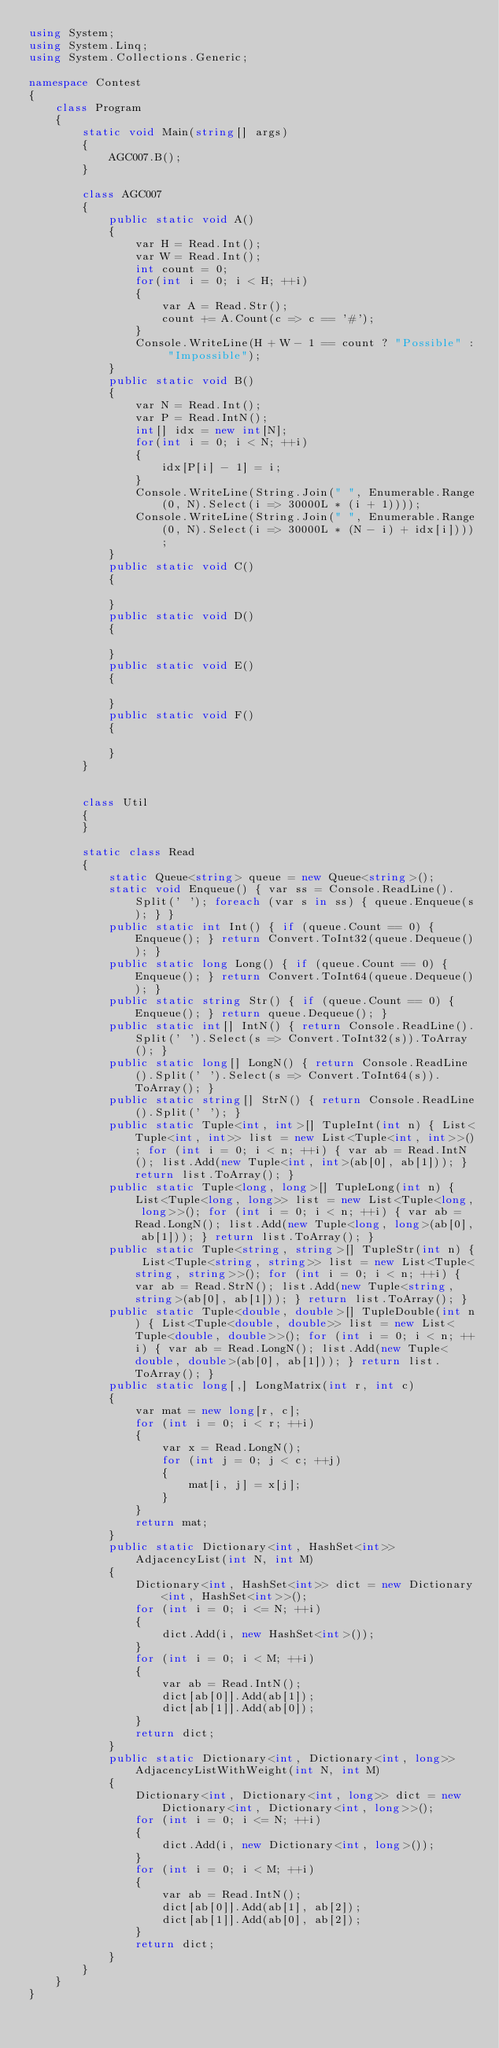Convert code to text. <code><loc_0><loc_0><loc_500><loc_500><_C#_>using System;
using System.Linq;
using System.Collections.Generic;

namespace Contest
{
    class Program
    {
        static void Main(string[] args)
        {
            AGC007.B();
        }

        class AGC007
        {
            public static void A()
            {
                var H = Read.Int();
                var W = Read.Int();
                int count = 0;
                for(int i = 0; i < H; ++i)
                {
                    var A = Read.Str();
                    count += A.Count(c => c == '#');
                }
                Console.WriteLine(H + W - 1 == count ? "Possible" : "Impossible");
            }
            public static void B()
            {
                var N = Read.Int();
                var P = Read.IntN();
                int[] idx = new int[N];
                for(int i = 0; i < N; ++i)
                {
                    idx[P[i] - 1] = i;
                }
                Console.WriteLine(String.Join(" ", Enumerable.Range(0, N).Select(i => 30000L * (i + 1))));
                Console.WriteLine(String.Join(" ", Enumerable.Range(0, N).Select(i => 30000L * (N - i) + idx[i])));
            }
            public static void C()
            {

            }
            public static void D()
            {

            }
            public static void E()
            {

            }
            public static void F()
            {

            }
        }


        class Util
        {
        }

        static class Read
        {
            static Queue<string> queue = new Queue<string>();
            static void Enqueue() { var ss = Console.ReadLine().Split(' '); foreach (var s in ss) { queue.Enqueue(s); } }
            public static int Int() { if (queue.Count == 0) { Enqueue(); } return Convert.ToInt32(queue.Dequeue()); }
            public static long Long() { if (queue.Count == 0) { Enqueue(); } return Convert.ToInt64(queue.Dequeue()); }
            public static string Str() { if (queue.Count == 0) { Enqueue(); } return queue.Dequeue(); }
            public static int[] IntN() { return Console.ReadLine().Split(' ').Select(s => Convert.ToInt32(s)).ToArray(); }
            public static long[] LongN() { return Console.ReadLine().Split(' ').Select(s => Convert.ToInt64(s)).ToArray(); }
            public static string[] StrN() { return Console.ReadLine().Split(' '); }
            public static Tuple<int, int>[] TupleInt(int n) { List<Tuple<int, int>> list = new List<Tuple<int, int>>(); for (int i = 0; i < n; ++i) { var ab = Read.IntN(); list.Add(new Tuple<int, int>(ab[0], ab[1])); } return list.ToArray(); }
            public static Tuple<long, long>[] TupleLong(int n) { List<Tuple<long, long>> list = new List<Tuple<long, long>>(); for (int i = 0; i < n; ++i) { var ab = Read.LongN(); list.Add(new Tuple<long, long>(ab[0], ab[1])); } return list.ToArray(); }
            public static Tuple<string, string>[] TupleStr(int n) { List<Tuple<string, string>> list = new List<Tuple<string, string>>(); for (int i = 0; i < n; ++i) { var ab = Read.StrN(); list.Add(new Tuple<string, string>(ab[0], ab[1])); } return list.ToArray(); }
            public static Tuple<double, double>[] TupleDouble(int n) { List<Tuple<double, double>> list = new List<Tuple<double, double>>(); for (int i = 0; i < n; ++i) { var ab = Read.LongN(); list.Add(new Tuple<double, double>(ab[0], ab[1])); } return list.ToArray(); }
            public static long[,] LongMatrix(int r, int c)
            {
                var mat = new long[r, c];
                for (int i = 0; i < r; ++i)
                {
                    var x = Read.LongN();
                    for (int j = 0; j < c; ++j)
                    {
                        mat[i, j] = x[j];
                    }
                }
                return mat;
            }
            public static Dictionary<int, HashSet<int>> AdjacencyList(int N, int M)
            {
                Dictionary<int, HashSet<int>> dict = new Dictionary<int, HashSet<int>>();
                for (int i = 0; i <= N; ++i)
                {
                    dict.Add(i, new HashSet<int>());
                }
                for (int i = 0; i < M; ++i)
                {
                    var ab = Read.IntN();
                    dict[ab[0]].Add(ab[1]);
                    dict[ab[1]].Add(ab[0]);
                }
                return dict;
            }
            public static Dictionary<int, Dictionary<int, long>> AdjacencyListWithWeight(int N, int M)
            {
                Dictionary<int, Dictionary<int, long>> dict = new Dictionary<int, Dictionary<int, long>>();
                for (int i = 0; i <= N; ++i)
                {
                    dict.Add(i, new Dictionary<int, long>());
                }
                for (int i = 0; i < M; ++i)
                {
                    var ab = Read.IntN();
                    dict[ab[0]].Add(ab[1], ab[2]);
                    dict[ab[1]].Add(ab[0], ab[2]);
                }
                return dict;
            }
        }
    }
}
</code> 